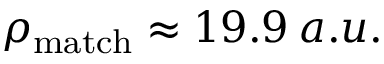<formula> <loc_0><loc_0><loc_500><loc_500>\rho _ { m a t c h } \approx 1 9 . 9 \, a . u .</formula> 